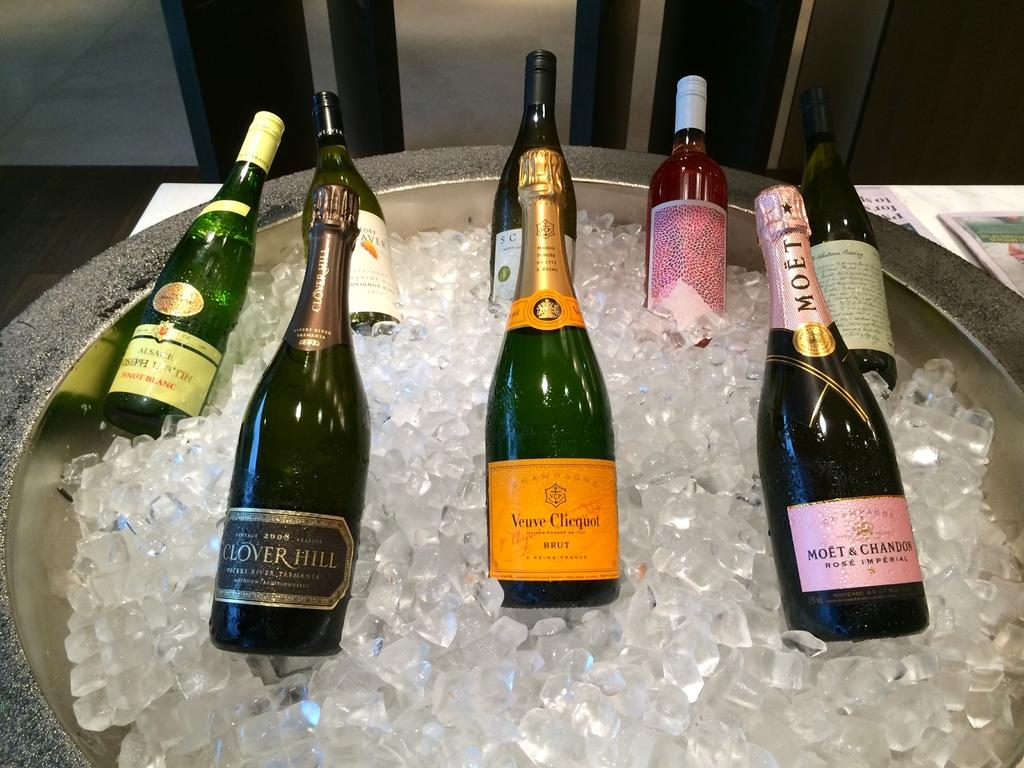<image>
Render a clear and concise summary of the photo. Eight bottles of champagne sitting in a tube of Ice, and one of them is made by Moet. 